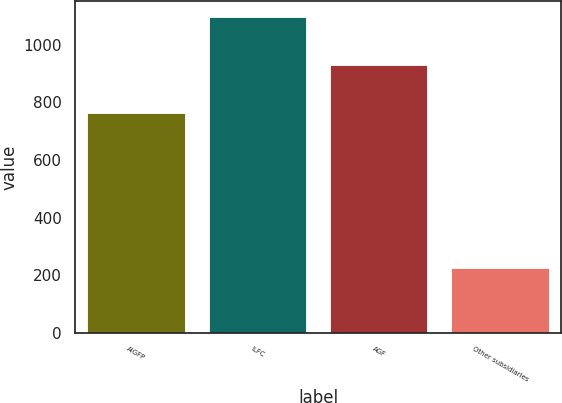Convert chart to OTSL. <chart><loc_0><loc_0><loc_500><loc_500><bar_chart><fcel>AIGFP<fcel>ILFC<fcel>AGF<fcel>Other subsidiaries<nl><fcel>765<fcel>1097<fcel>931<fcel>227<nl></chart> 